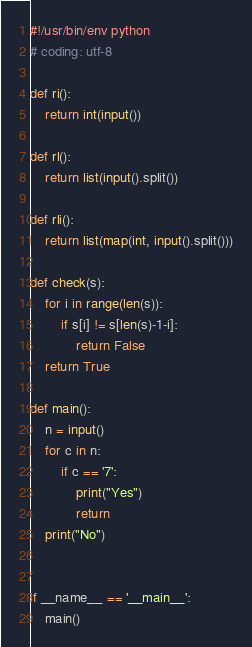<code> <loc_0><loc_0><loc_500><loc_500><_Python_>#!/usr/bin/env python
# coding: utf-8

def ri():
    return int(input())

def rl():
    return list(input().split())

def rli():
    return list(map(int, input().split()))

def check(s):
    for i in range(len(s)):
        if s[i] != s[len(s)-1-i]:
            return False
    return True

def main():
    n = input()
    for c in n:
        if c == '7':
            print("Yes")
            return
    print("No")


if __name__ == '__main__':
    main()
</code> 